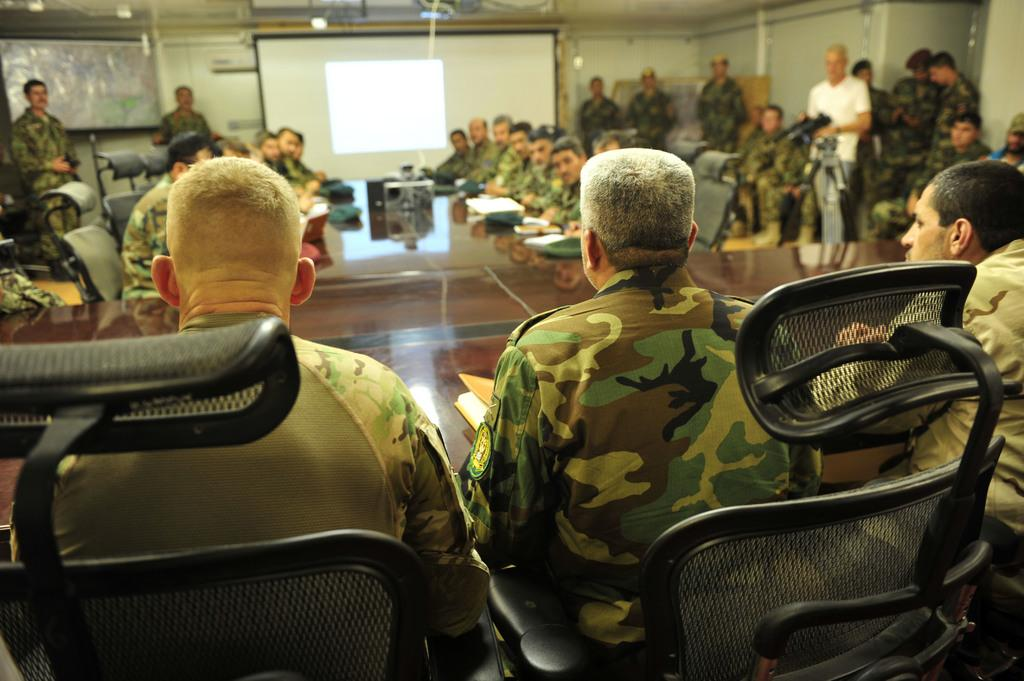How many people are in the image? There is a group of people in the image. What are the people doing in the image? The people are sitting around a table. What type of furniture is present in the image? There are chairs in the image. What is displayed on the table in the image? There is a projector image in the middle of the table. What can be seen in the background of the image? There is a wall visible in the image. How many minutes does it take for the truck to pass by in the image? There is no truck present in the image, so it is not possible to determine how many minutes it would take for a truck to pass by. 